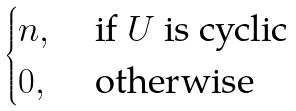Convert formula to latex. <formula><loc_0><loc_0><loc_500><loc_500>\begin{cases} n , & \text { if $ U $ is cyclic } \\ 0 , & \text { otherwise } \end{cases}</formula> 